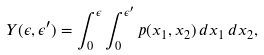<formula> <loc_0><loc_0><loc_500><loc_500>Y ( \epsilon , \epsilon ^ { \prime } ) = \int _ { 0 } ^ { \epsilon } \int _ { 0 } ^ { \epsilon ^ { \prime } } p ( x _ { 1 } , x _ { 2 } ) \, d x _ { 1 } \, d x _ { 2 } ,</formula> 